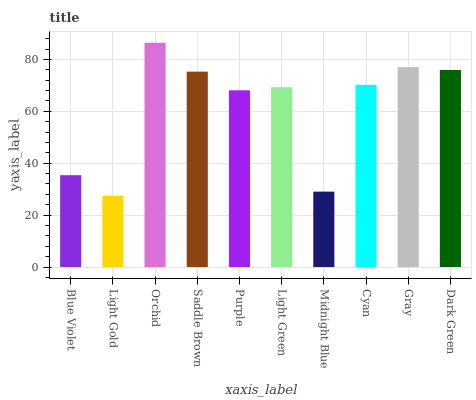Is Light Gold the minimum?
Answer yes or no. Yes. Is Orchid the maximum?
Answer yes or no. Yes. Is Orchid the minimum?
Answer yes or no. No. Is Light Gold the maximum?
Answer yes or no. No. Is Orchid greater than Light Gold?
Answer yes or no. Yes. Is Light Gold less than Orchid?
Answer yes or no. Yes. Is Light Gold greater than Orchid?
Answer yes or no. No. Is Orchid less than Light Gold?
Answer yes or no. No. Is Cyan the high median?
Answer yes or no. Yes. Is Light Green the low median?
Answer yes or no. Yes. Is Gray the high median?
Answer yes or no. No. Is Midnight Blue the low median?
Answer yes or no. No. 